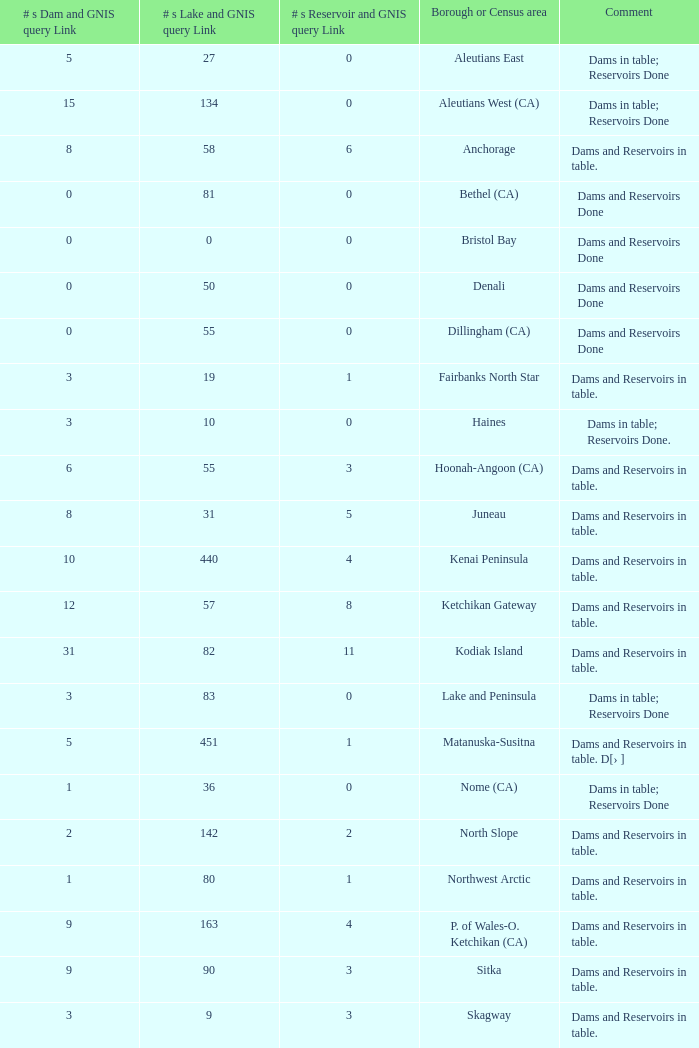Name the minimum number of reservoir for gnis query link where numbers lake gnis query link being 60 5.0. 